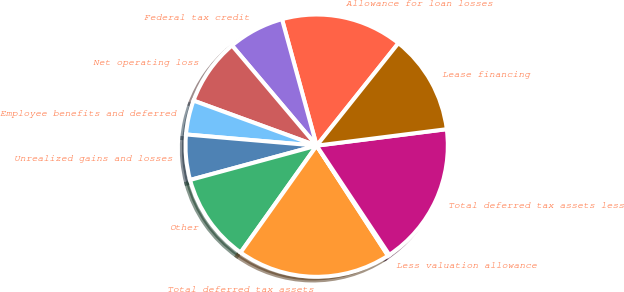Convert chart. <chart><loc_0><loc_0><loc_500><loc_500><pie_chart><fcel>Allowance for loan losses<fcel>Federal tax credit<fcel>Net operating loss<fcel>Employee benefits and deferred<fcel>Unrealized gains and losses<fcel>Other<fcel>Total deferred tax assets<fcel>Less valuation allowance<fcel>Total deferred tax assets less<fcel>Lease financing<nl><fcel>14.97%<fcel>6.91%<fcel>8.25%<fcel>4.22%<fcel>5.57%<fcel>10.94%<fcel>19.0%<fcel>0.19%<fcel>17.66%<fcel>12.28%<nl></chart> 